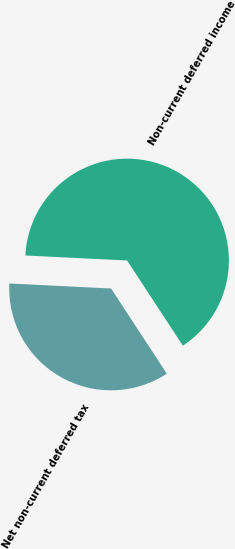<chart> <loc_0><loc_0><loc_500><loc_500><pie_chart><fcel>Non-current deferred income<fcel>Net non-current deferred tax<nl><fcel>64.99%<fcel>35.01%<nl></chart> 